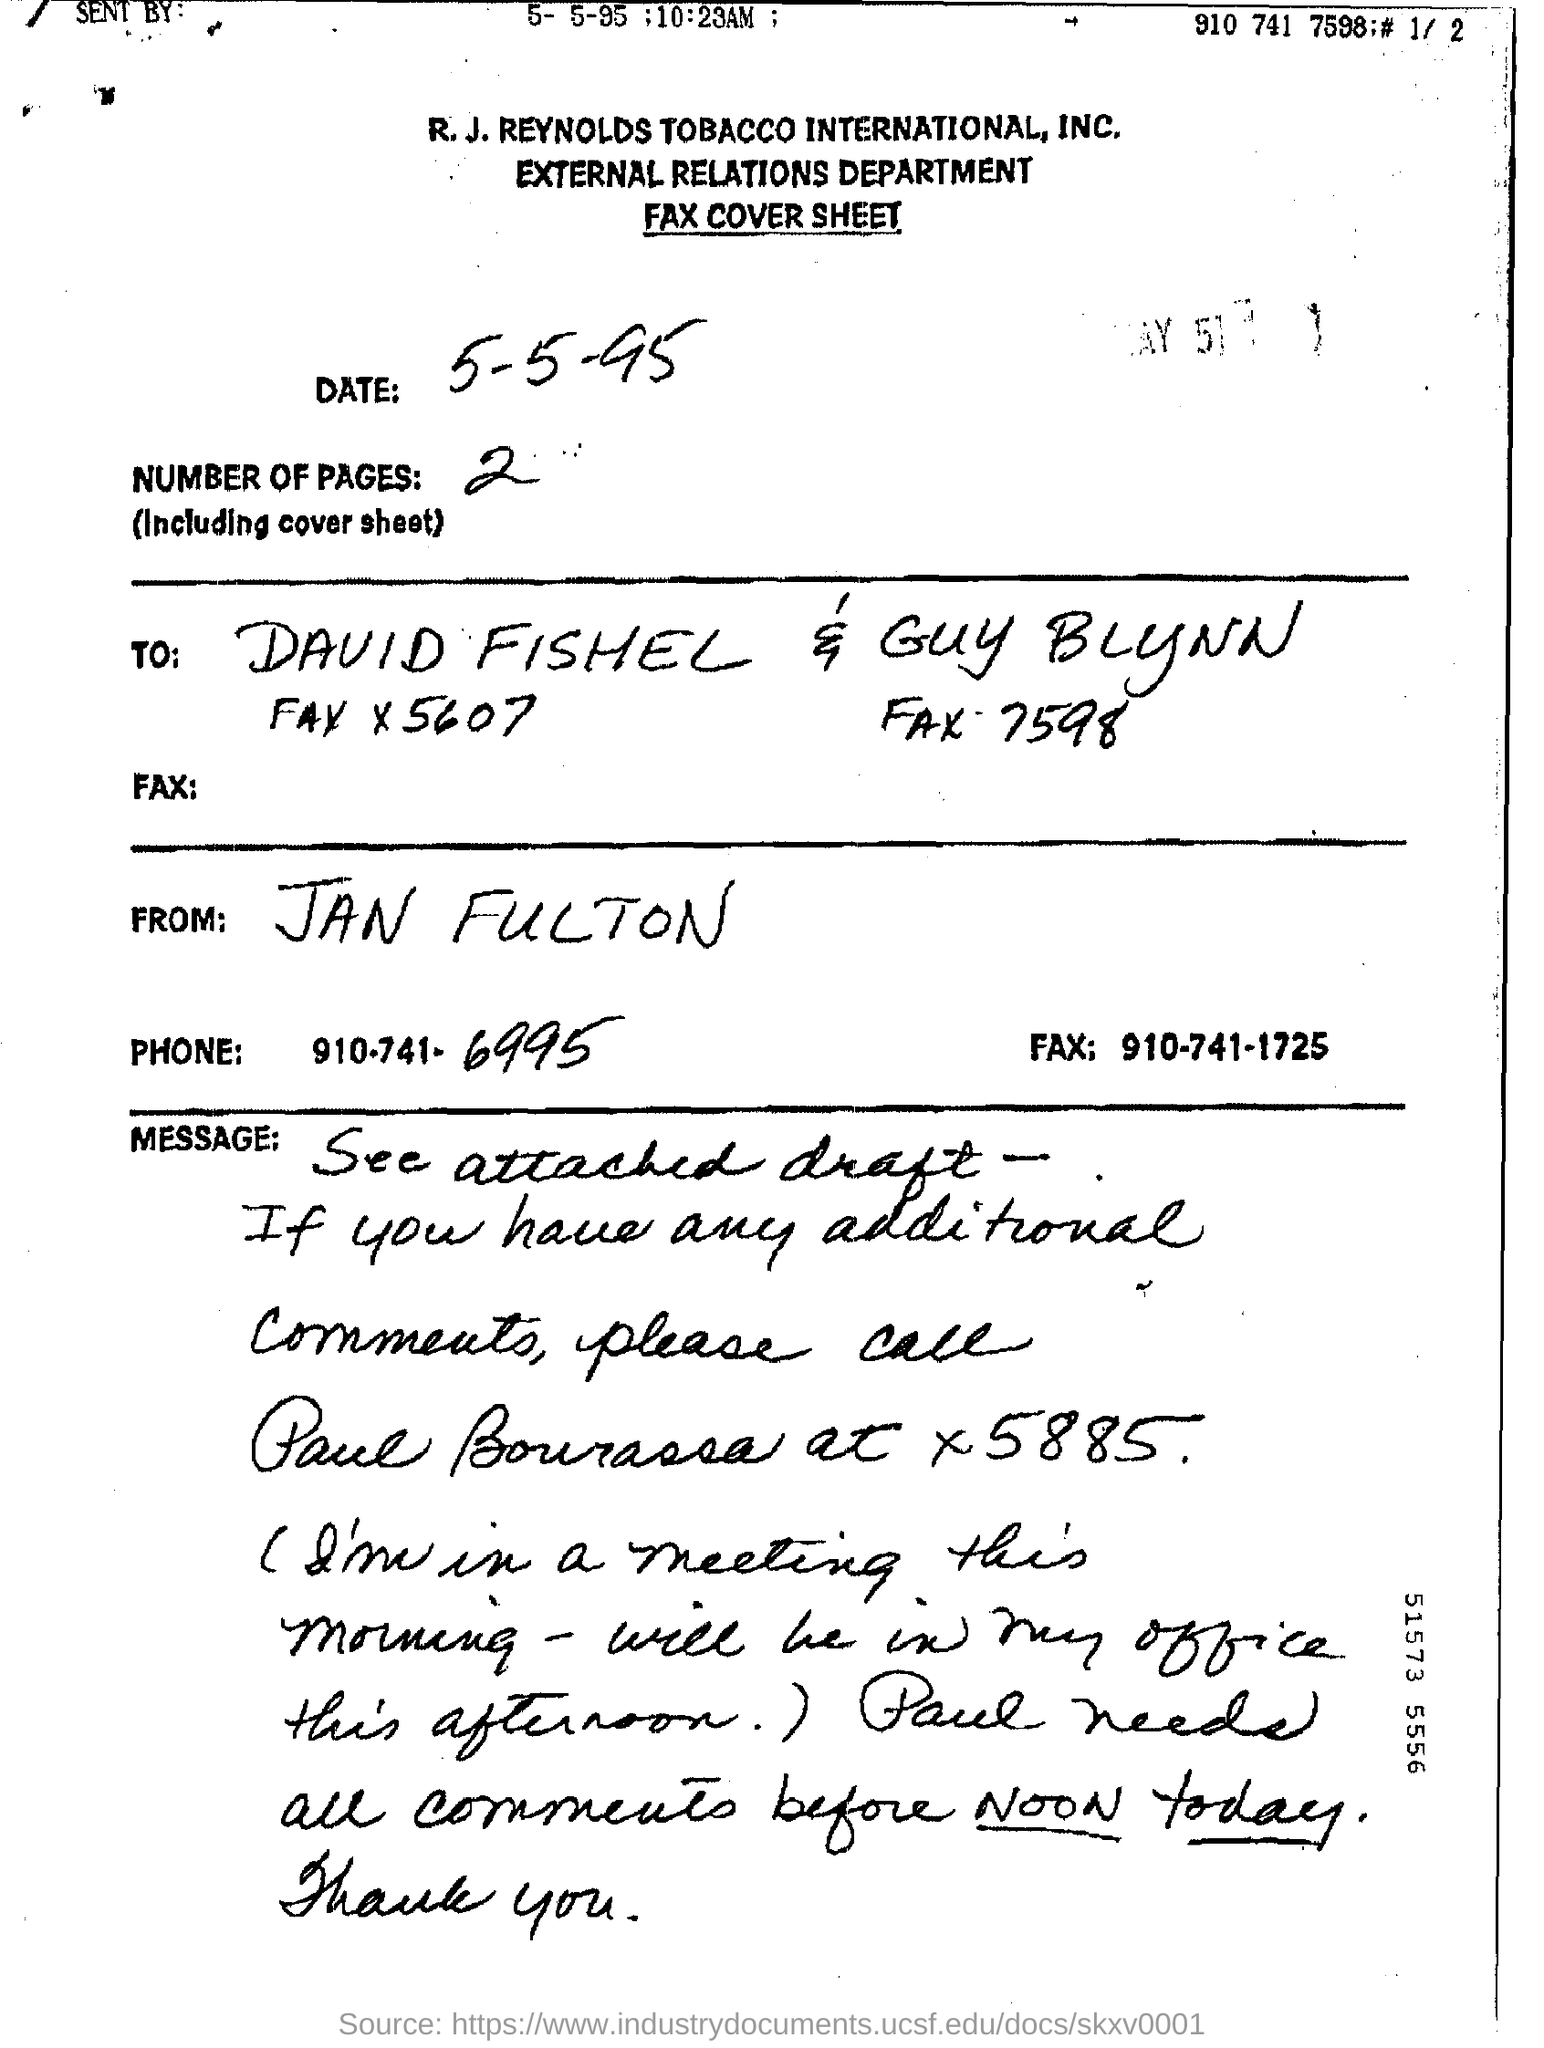Outline some significant characteristics in this image. It is a fax cover sheet. The title reads 'External Relations'. The last four digits of the phone number are 6995. 